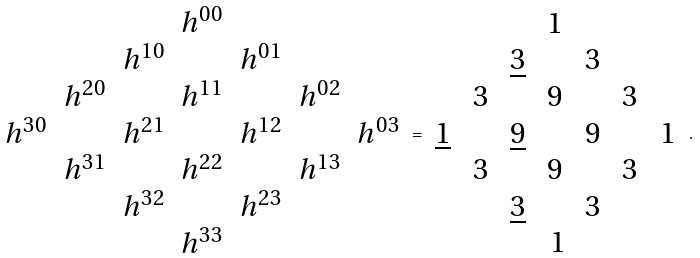<formula> <loc_0><loc_0><loc_500><loc_500>\begin{array} { c c c c c c c } & & & h ^ { 0 0 } & & & \\ & & h ^ { 1 0 } & & h ^ { 0 1 } & & \\ & h ^ { 2 0 } & & h ^ { 1 1 } & & h ^ { 0 2 } & \\ h ^ { 3 0 } & & h ^ { 2 1 } & & h ^ { 1 2 } & & h ^ { 0 3 } \\ & h ^ { 3 1 } & & h ^ { 2 2 } & & h ^ { 1 3 } & \\ & & h ^ { 3 2 } & & h ^ { 2 3 } & & \\ & & & h ^ { 3 3 } & & & \\ \end{array} = \begin{array} { c c c c c c c } & & & 1 \, & & & \\ & & \underline { 3 } \, & & 3 \, & & \\ & 3 \, & & 9 \, & & 3 \, & \\ \underline { 1 } \, & & \underline { 9 } \, & & 9 \, & & 1 \, \\ & 3 \, & & 9 \, & & 3 \, & \\ & & \underline { 3 } \, & & 3 \, & & \\ & & & 1 & & & \\ \end{array} .</formula> 